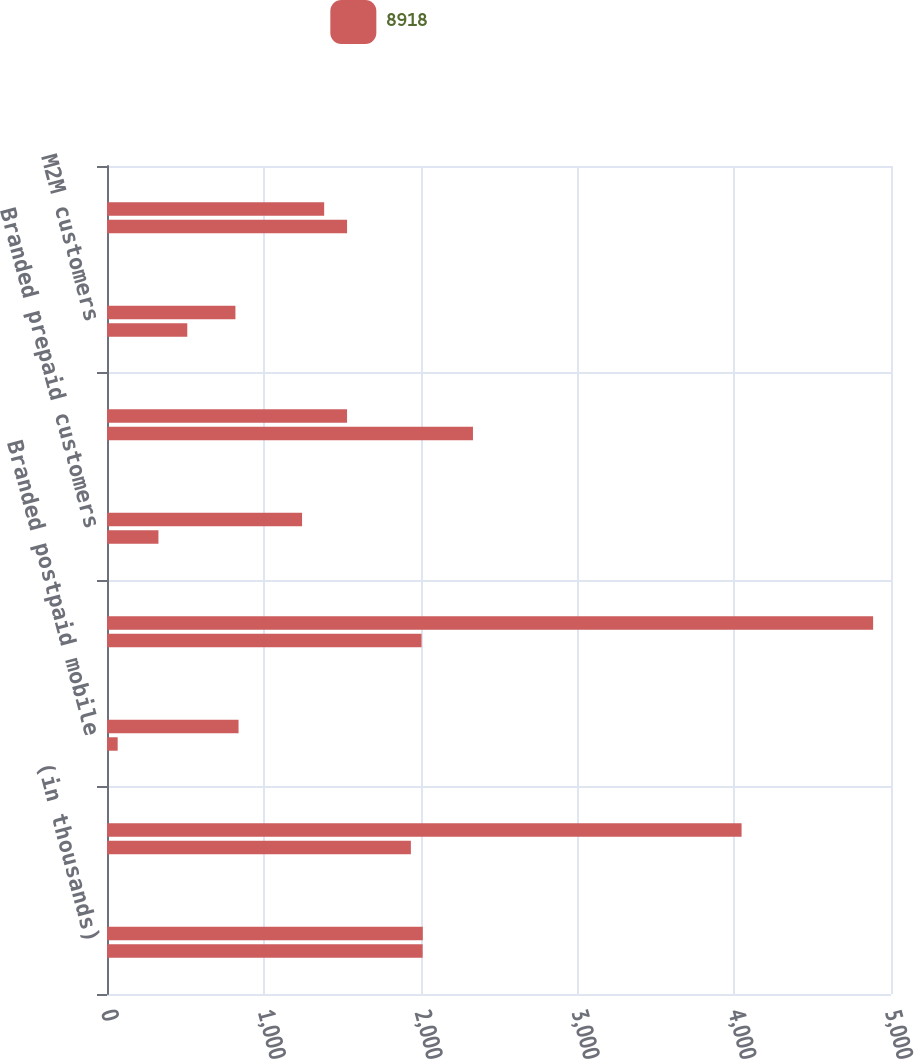Convert chart to OTSL. <chart><loc_0><loc_0><loc_500><loc_500><stacked_bar_chart><ecel><fcel>(in thousands)<fcel>Branded postpaid phone<fcel>Branded postpaid mobile<fcel>Total branded postpaid<fcel>Branded prepaid customers<fcel>Total branded customers<fcel>M2M customers<fcel>MVNO customers<nl><fcel>nan<fcel>2014<fcel>4047<fcel>839<fcel>4886<fcel>1244<fcel>1531<fcel>819<fcel>1385<nl><fcel>8918<fcel>2013<fcel>1938<fcel>68<fcel>2006<fcel>328<fcel>2334<fcel>512<fcel>1531<nl></chart> 